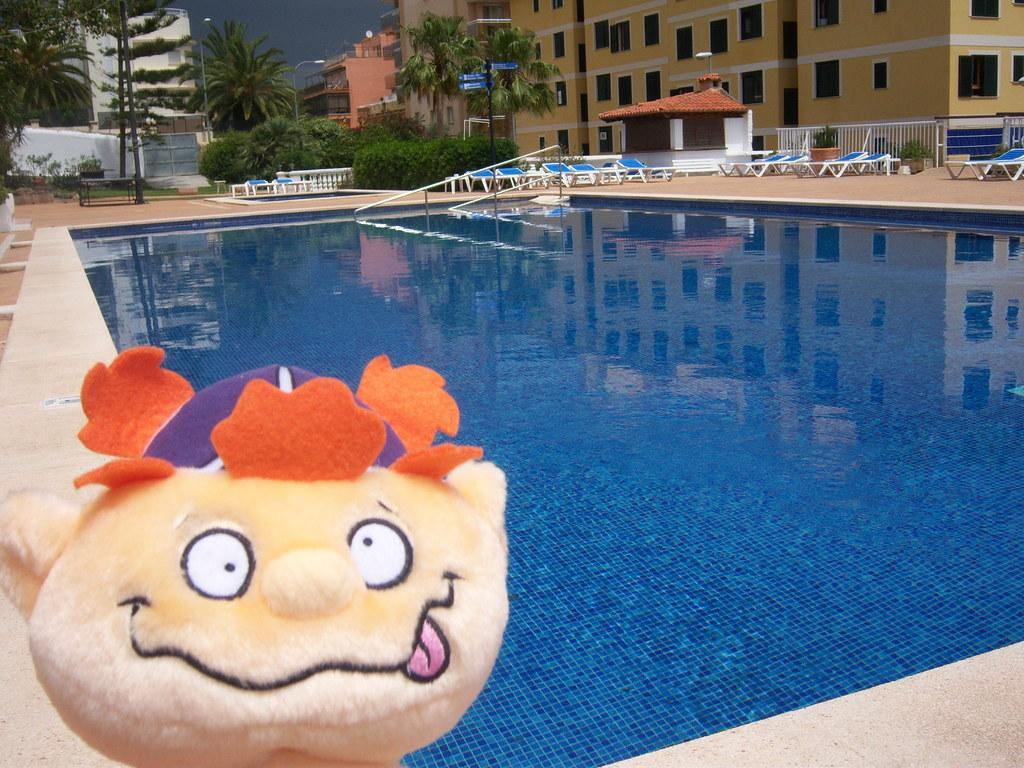What is present in the image that represents a toy or figurine? There is a doll in the image. What type of recreational area can be seen in the image? There is a swimming pool in the image, which contains water. What type of furniture is present in the image? There are chairs in the image. What type of vegetation is present in the image? There are plants and trees in the image. What type of structures can be seen in the background of the image? There are buildings in the background of the image. What type of car is parked near the swimming pool in the image? There is no car present in the image; it only features a doll, a swimming pool, chairs, plants, trees, and buildings in the background. What type of treatment is being administered to the doll in the image? There is no treatment being administered to the doll in the image; it is simply a toy or figurine present in the scene. 